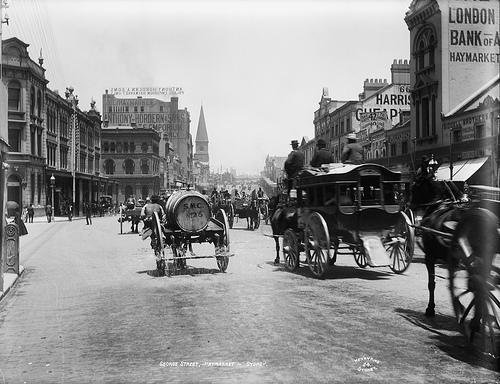Do these vehicle consume gasoline?
Answer briefly. No. Is this a contemporary scene?
Give a very brief answer. No. How many teams of horses are pulling?
Keep it brief. 5. How many horses are there?
Short answer required. 3. 